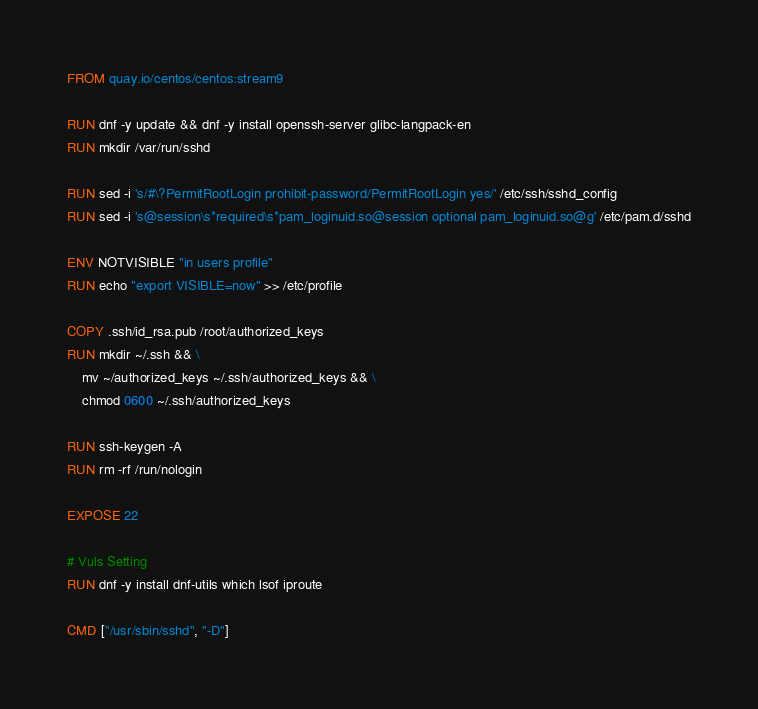Convert code to text. <code><loc_0><loc_0><loc_500><loc_500><_Dockerfile_>FROM quay.io/centos/centos:stream9

RUN dnf -y update && dnf -y install openssh-server glibc-langpack-en
RUN mkdir /var/run/sshd

RUN sed -i 's/#\?PermitRootLogin prohibit-password/PermitRootLogin yes/' /etc/ssh/sshd_config
RUN sed -i 's@session\s*required\s*pam_loginuid.so@session optional pam_loginuid.so@g' /etc/pam.d/sshd

ENV NOTVISIBLE "in users profile"
RUN echo "export VISIBLE=now" >> /etc/profile

COPY .ssh/id_rsa.pub /root/authorized_keys
RUN mkdir ~/.ssh && \
    mv ~/authorized_keys ~/.ssh/authorized_keys && \
    chmod 0600 ~/.ssh/authorized_keys

RUN ssh-keygen -A
RUN rm -rf /run/nologin

EXPOSE 22

# Vuls Setting
RUN dnf -y install dnf-utils which lsof iproute

CMD ["/usr/sbin/sshd", "-D"]</code> 